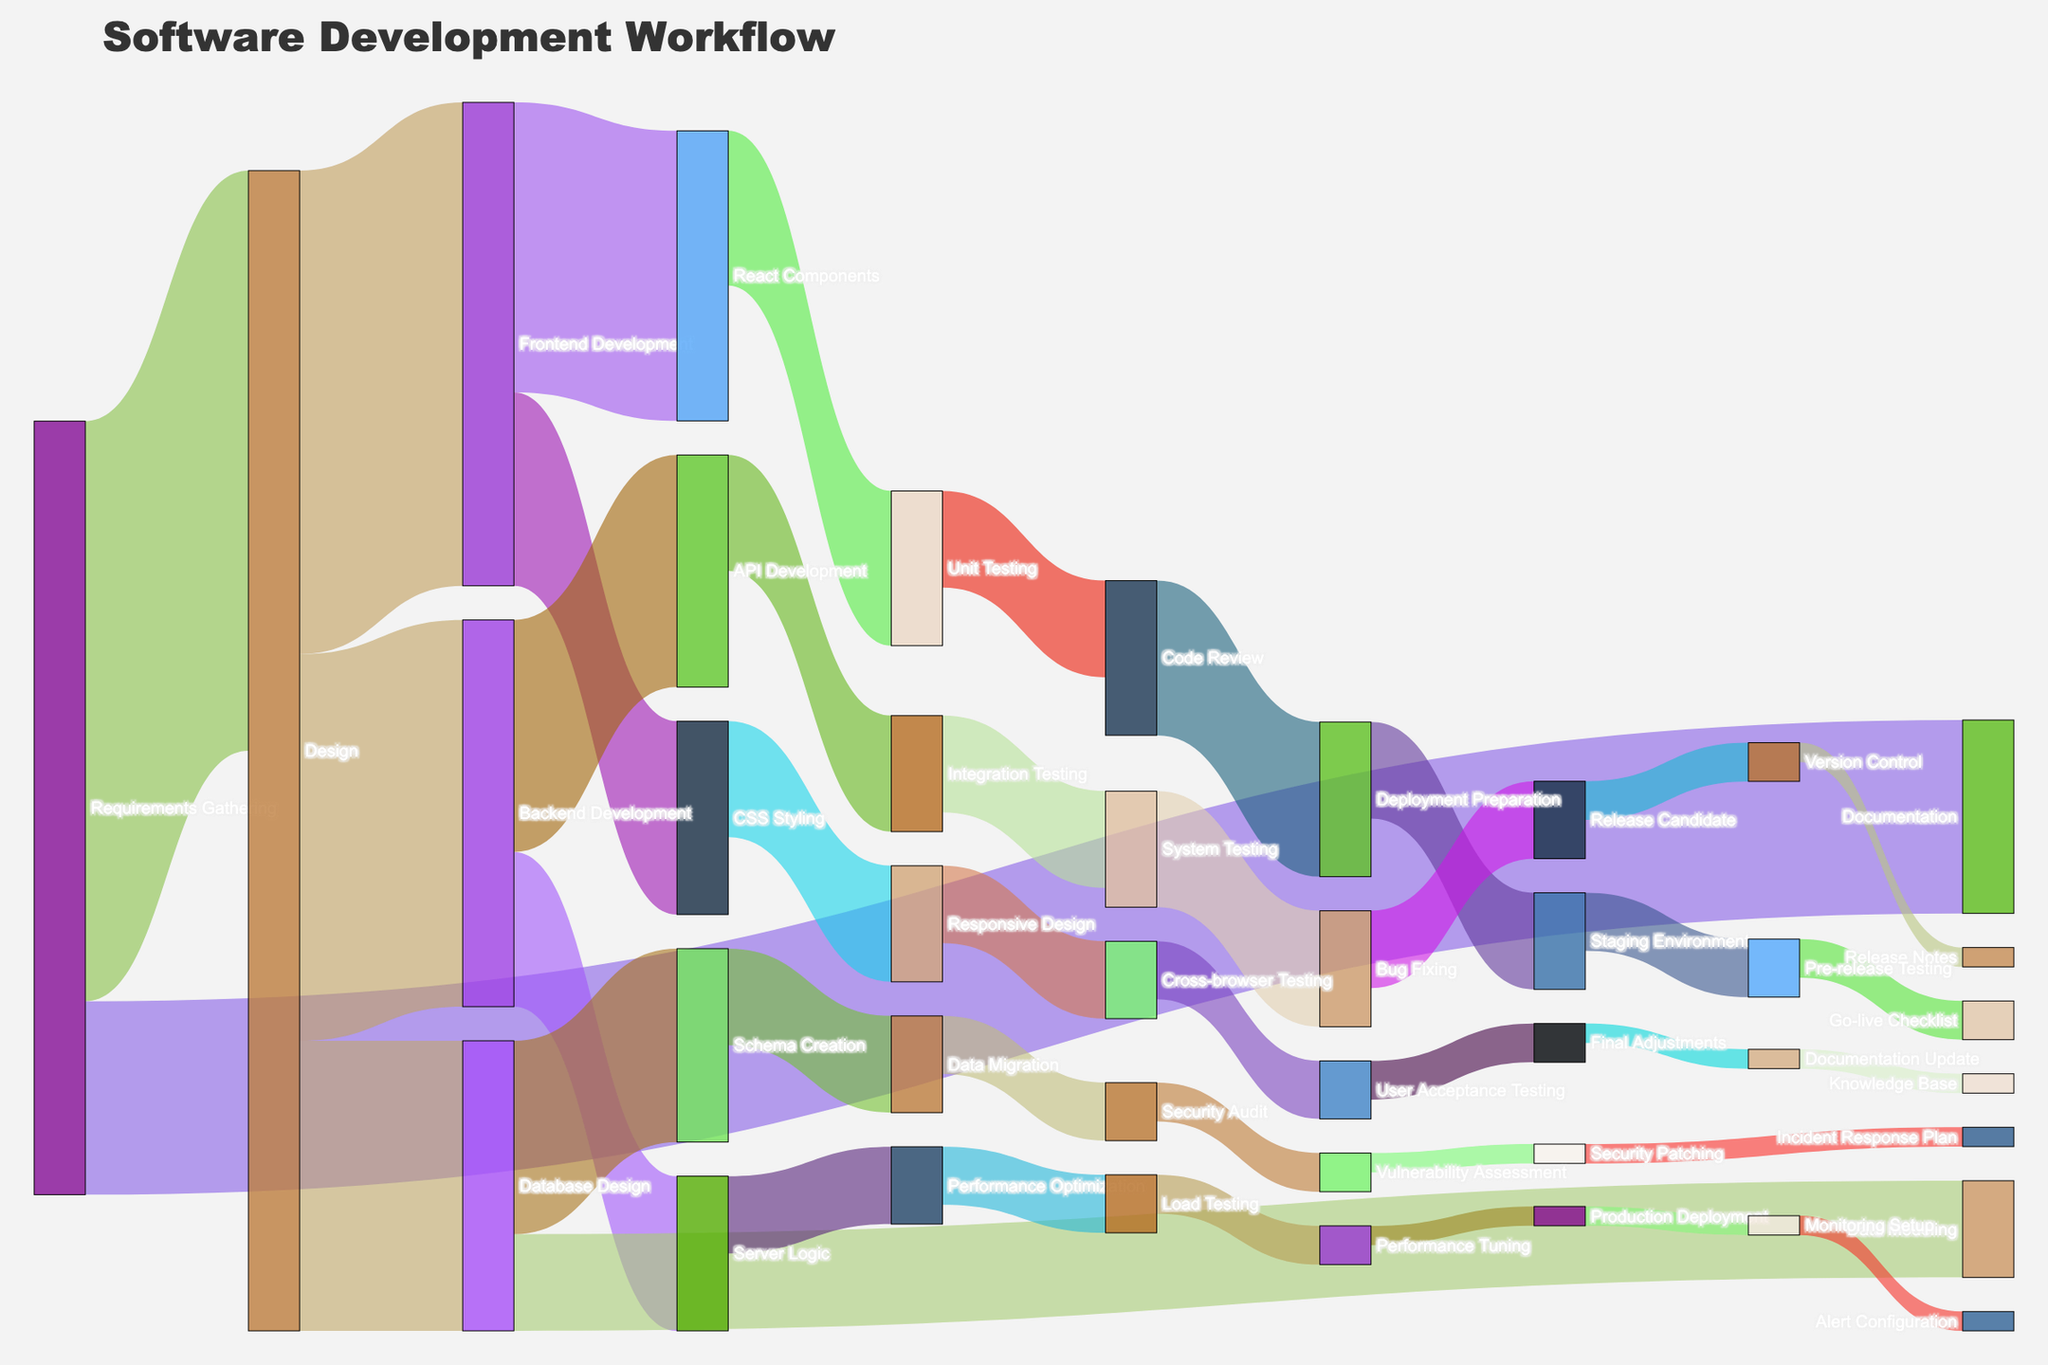Which stage allocates the most resources? By analyzing the figure, we look for the stage where the widest flow starts from. The "Design" stage has the most resources allocated, with flows towards Frontend Development, Backend Development, and Database Design totaling a large value.
Answer: Design What are the final stages in the workflow? To determine the final stages, look for nodes that have arrows pointing to them but do not point to any other nodes. These include "Knowledge Base," "Release Notes," "Alert Configuration," and "Incident Response Plan."
Answer: Knowledge Base, Release Notes, Alert Configuration, and Incident Response Plan How many resources are allocated to Frontend Development from Design? Find the flow from "Design" to "Frontend Development" and identify its value. The value of resources allocated to Frontend Development from Design is 25.
Answer: 25 Compare the resources allocated to Unit Testing and Integration Testing. Which one has more resources? Check the values of the flows into "Unit Testing" and "Integration Testing." Unit Testing receives 8 resources from React Components, while Integration Testing receives 6 resources from API Development. Therefore, Unit Testing has more resources.
Answer: Unit Testing What is the combined resource allocation for Database Design tasks? Add the values of the flows from Database Design to its sub-tasks: Schema Creation (10) and Data Modeling (5). The combined resource allocation is 10 + 5 = 15.
Answer: 15 Which tasks receive the least resources in the workflow? Identify the narrowest flows or those with the smallest values. The tasks "Documentation Update," "Version Control," "Production Deployment," "Security Patching," "Final Adjustments," and "Knowledge Base" each receive 1 resource.
Answer: Documentation Update, Version Control, Production Deployment, Security Patching, Final Adjustments, Knowledge Base What stages follow Backend Development? Look at the nodes immediately connected to "Backend Development" by arrows. These are "API Development" and "Server Logic."
Answer: API Development and Server Logic How do resources flow from Performance Optimization? Trace the arrows from "Performance Optimization" to see where the resources go. Resources flow to "Load Testing" (3) and from there to "Performance Tuning" (2).
Answer: Load Testing -> Performance Tuning Compare the resource flow from the "Design" to "Frontend Development" and "Backend Development." Is there a difference? Examine the flows from "Design" to "Frontend Development" (25) and "Backend Development" (20). "Frontend Development" receives more resources than "Backend Development."
Answer: Yes, Frontend Development receives 5 more resources What is the penultimate stage before the "Release Candidate"? Identify the node that directly precedes "Release Candidate." This node is "Bug Fixing."
Answer: Bug Fixing 